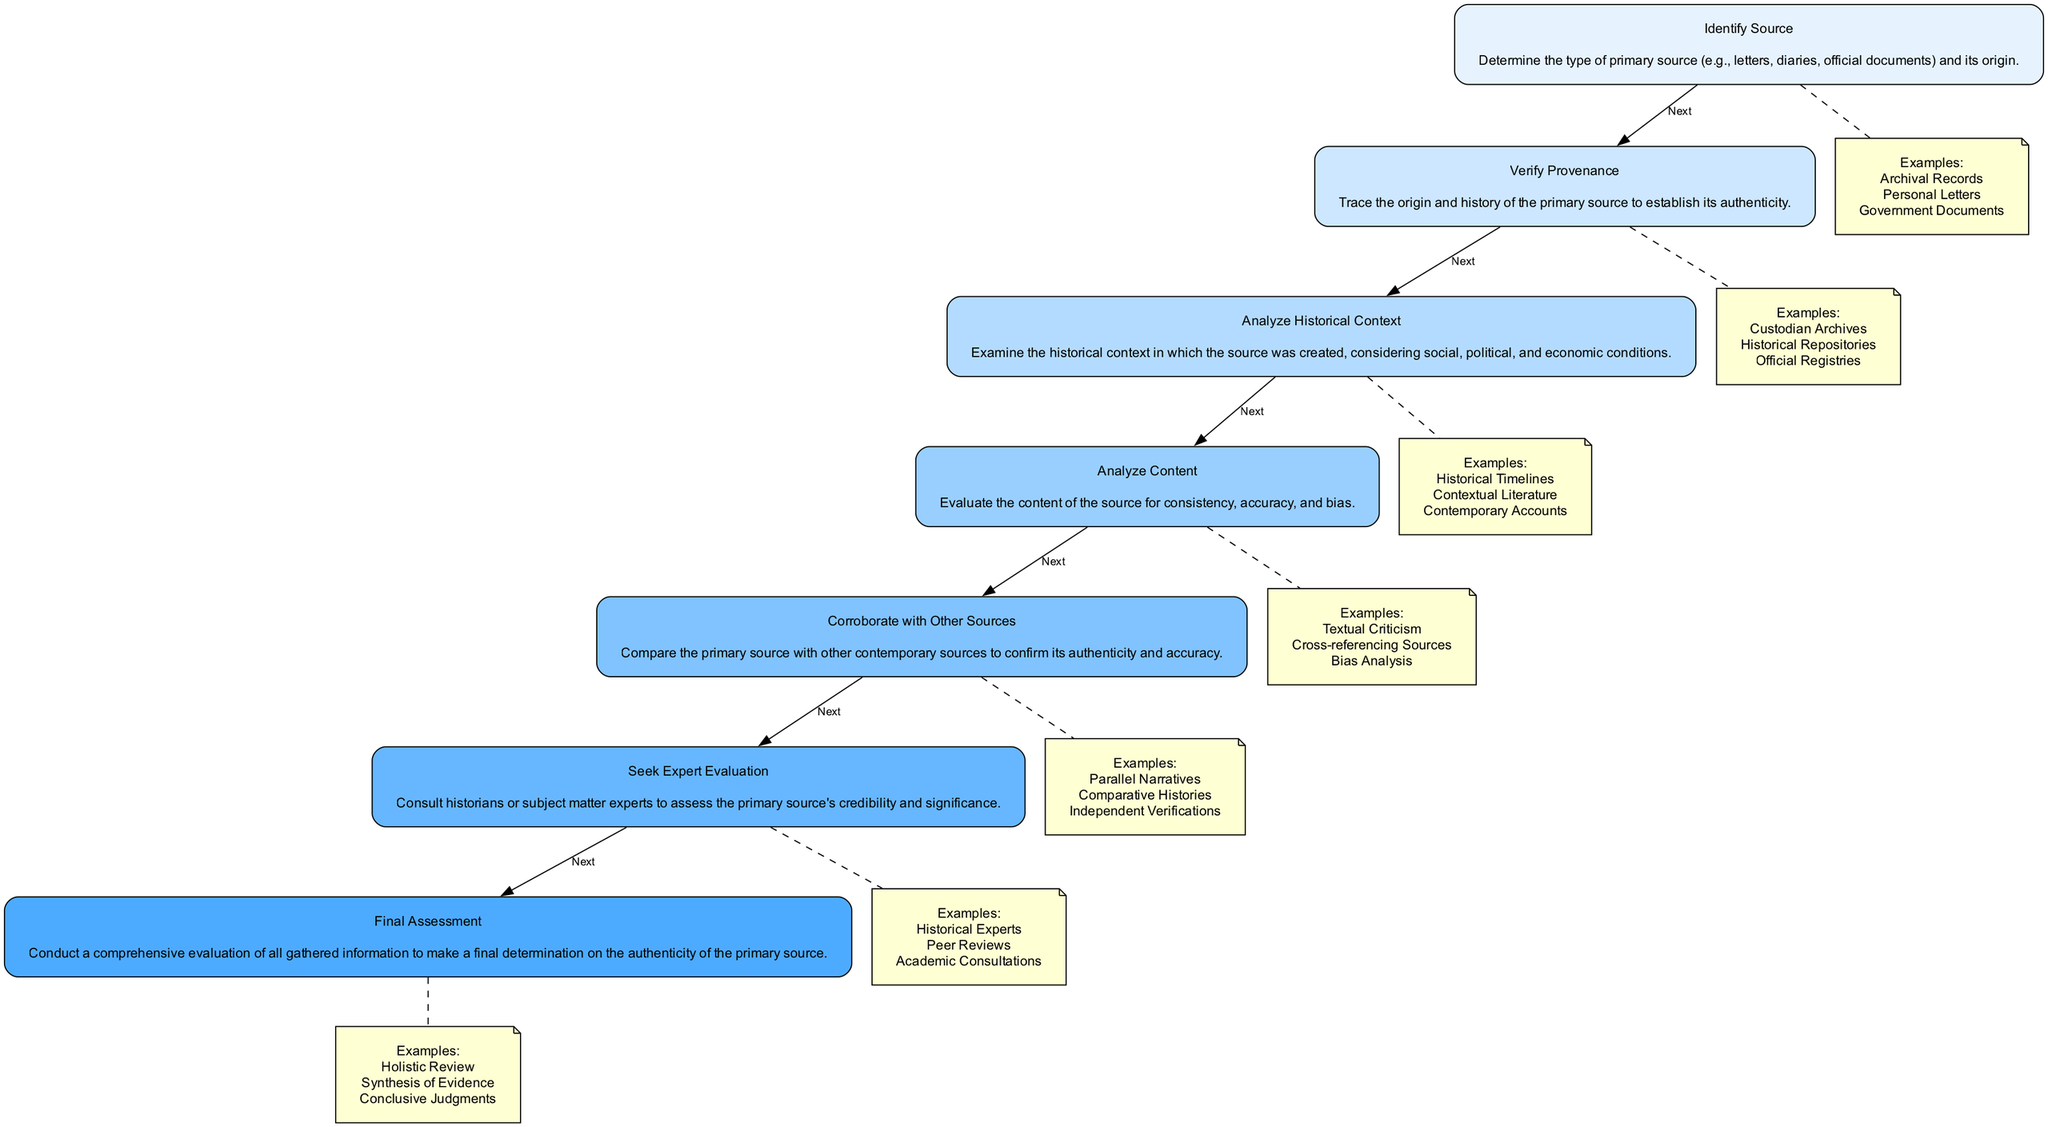What is the first step in the authenticity flow? The first step in the flow is "Identify Source," which determines the type and origin of the primary source.
Answer: Identify Source How many total steps are in the authenticity flow? The flow consists of six steps, from "Identify Source" to "Final Assessment."
Answer: Six Which step follows "Analyze Historical Context"? The step that follows "Analyze Historical Context" is "Analyze Content." This is indicated as the next step in the flow.
Answer: Analyze Content What type of source does the "Verify Provenance" step focus on? The "Verify Provenance" step focuses on tracing the origin and history of the primary source to establish authenticity.
Answer: Primary source authenticity What examples are provided for the "Analyze Content" step? The examples for "Analyze Content" include "Textual Criticism," "Cross-referencing Sources," and "Bias Analysis." Each helps evaluate the source's content.
Answer: Textual Criticism, Cross-referencing Sources, Bias Analysis Which step includes consulting historians? The step that includes consulting historians is "Seek Expert Evaluation." This step involves having experts assess the primary source's credibility.
Answer: Seek Expert Evaluation What is the last step in the authenticity flow? The last step in the flow is "Final Assessment," which entails a comprehensive evaluation of all information gathered.
Answer: Final Assessment What is one of the entities listed under "Corroborate with Other Sources"? One of the entities listed is "Parallel Narratives," which is used to compare the primary source with other contemporary sources.
Answer: Parallel Narratives Which step has the description of "Conduct a comprehensive evaluation..."? This description belongs to the "Final Assessment" step, where all gathered information is evaluated to determine authenticity.
Answer: Final Assessment 